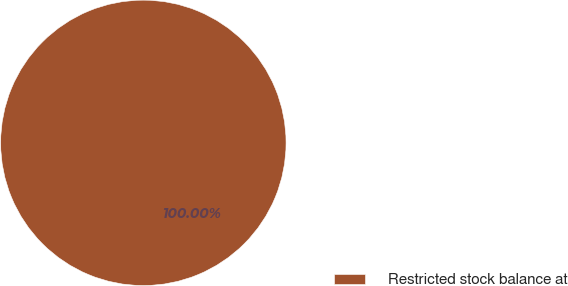Convert chart to OTSL. <chart><loc_0><loc_0><loc_500><loc_500><pie_chart><fcel>Restricted stock balance at<nl><fcel>100.0%<nl></chart> 